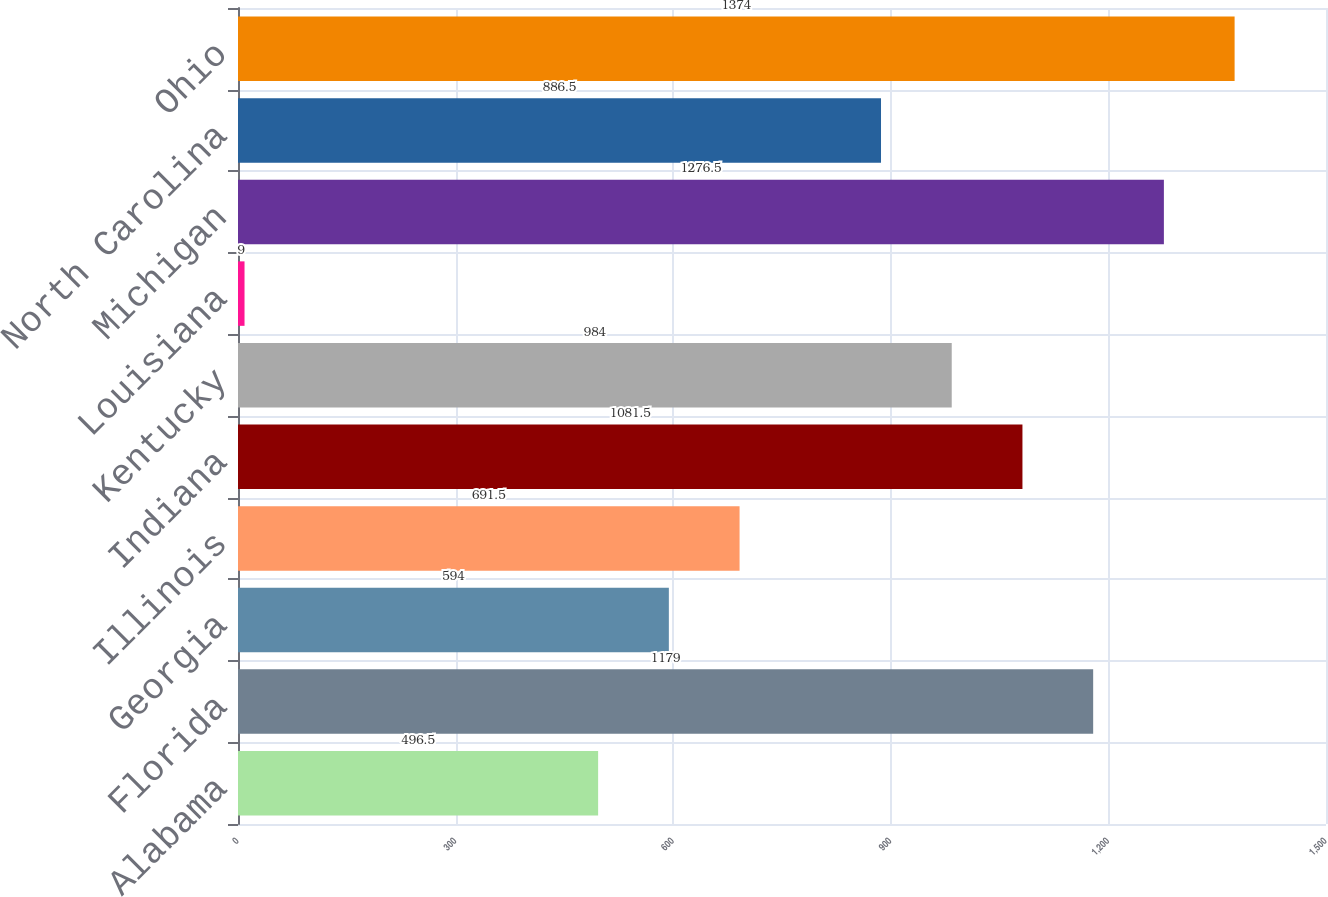<chart> <loc_0><loc_0><loc_500><loc_500><bar_chart><fcel>Alabama<fcel>Florida<fcel>Georgia<fcel>Illinois<fcel>Indiana<fcel>Kentucky<fcel>Louisiana<fcel>Michigan<fcel>North Carolina<fcel>Ohio<nl><fcel>496.5<fcel>1179<fcel>594<fcel>691.5<fcel>1081.5<fcel>984<fcel>9<fcel>1276.5<fcel>886.5<fcel>1374<nl></chart> 